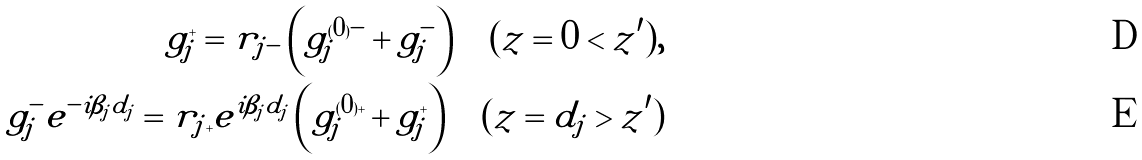Convert formula to latex. <formula><loc_0><loc_0><loc_500><loc_500>g _ { j } ^ { + } = r _ { j - } \left ( g _ { j } ^ { ( 0 ) - } + g _ { j } ^ { - } \right ) \quad ( z = 0 < z ^ { \prime } ) , \\ g _ { j } ^ { - } e ^ { - i \beta _ { j } d _ { j } } = r _ { j + } e ^ { i \beta _ { j } d _ { j } } \left ( g _ { j } ^ { ( 0 ) + } + g _ { j } ^ { + } \right ) \quad ( z = d _ { j } > z ^ { \prime } )</formula> 